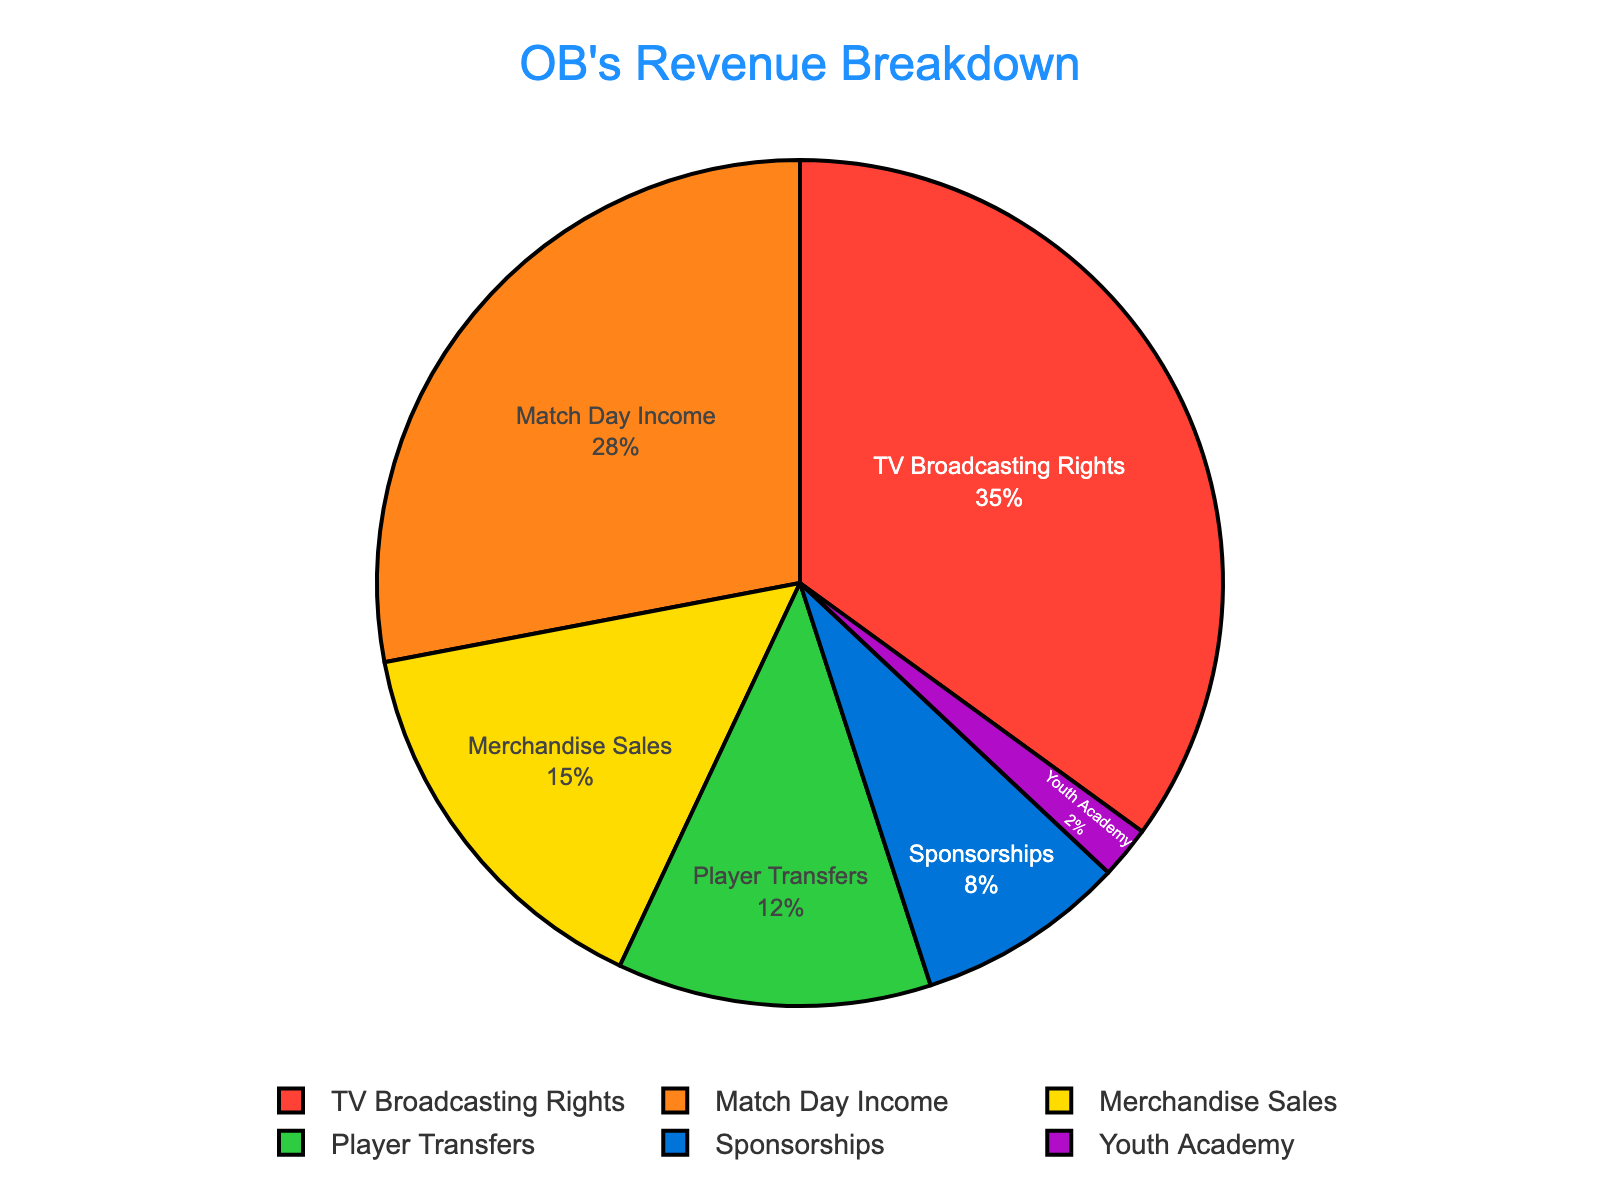Match Day Income contributes to what percentage of OB's total revenue? The Match Day Income segment in the pie chart shows 28%, indicating that this amount comes from match day-related activities such as ticket sales and concessions.
Answer: 28% Which revenue source contributes the most to OB's total revenue? Analyzing the pie chart, the largest segment by percentage representation is TV Broadcasting Rights at 35%.
Answer: TV Broadcasting Rights How much more does OB earn from Merchandise Sales compared to Youth Academy? Merchandise Sales contribute 15%, and the Youth Academy contributes 2%, so the difference is 15% - 2% = 13%.
Answer: 13% Which two revenue sources combined contribute to more than half of OB's total revenue? By summing up the two highest sources: TV Broadcasting Rights (35%) and Match Day Income (28%), we get 35% + 28% = 63%, which is more than half (50%) of the total revenue.
Answer: TV Broadcasting Rights and Match Day Income What is the total percentage contributed by Player Transfers and Sponsorships? Sum the percentages of Player Transfers (12%) and Sponsorships (8%) to get 12% + 8% = 20%.
Answer: 20% Among the given categories, which one represents the smallest revenue source for OB? The pie chart displays Youth Academy with the smallest percentage, contributing only 2% to the total revenue.
Answer: Youth Academy Is the revenue from Match Day Income greater than the sum of Player Transfers and Youth Academy? Compare the percentages: Match Day Income is 28%, and the sum of Player Transfers and Youth Academy is 12% + 2% = 14%. 28% is greater than 14%.
Answer: Yes What is the percentage difference between the largest and smallest revenue sources? The largest revenue source is TV Broadcasting Rights at 35%, and the smallest is Youth Academy at 2%. The difference is 35% - 2% = 33%.
Answer: 33% How does the percentage of TV Broadcasting Rights compare to the combined percentage of Merchandise Sales and Sponsorships? TV Broadcasting Rights is 35%. Merchandise Sales and Sponsorships together contribute 15% + 8% = 23%. Thus, TV Broadcasting Rights (35%) is greater than the combined amount (23%).
Answer: TV Broadcasting Rights is greater What percentage of the total revenue does OB earn from non-match-related activities (excluding Match Day Income)? Sum the percentages of all sources except Match Day Income: 35% (TV Broadcasting Rights) + 15% (Merchandise Sales) + 12% (Player Transfers) + 8% (Sponsorships) + 2% (Youth Academy) = 72%.
Answer: 72% 